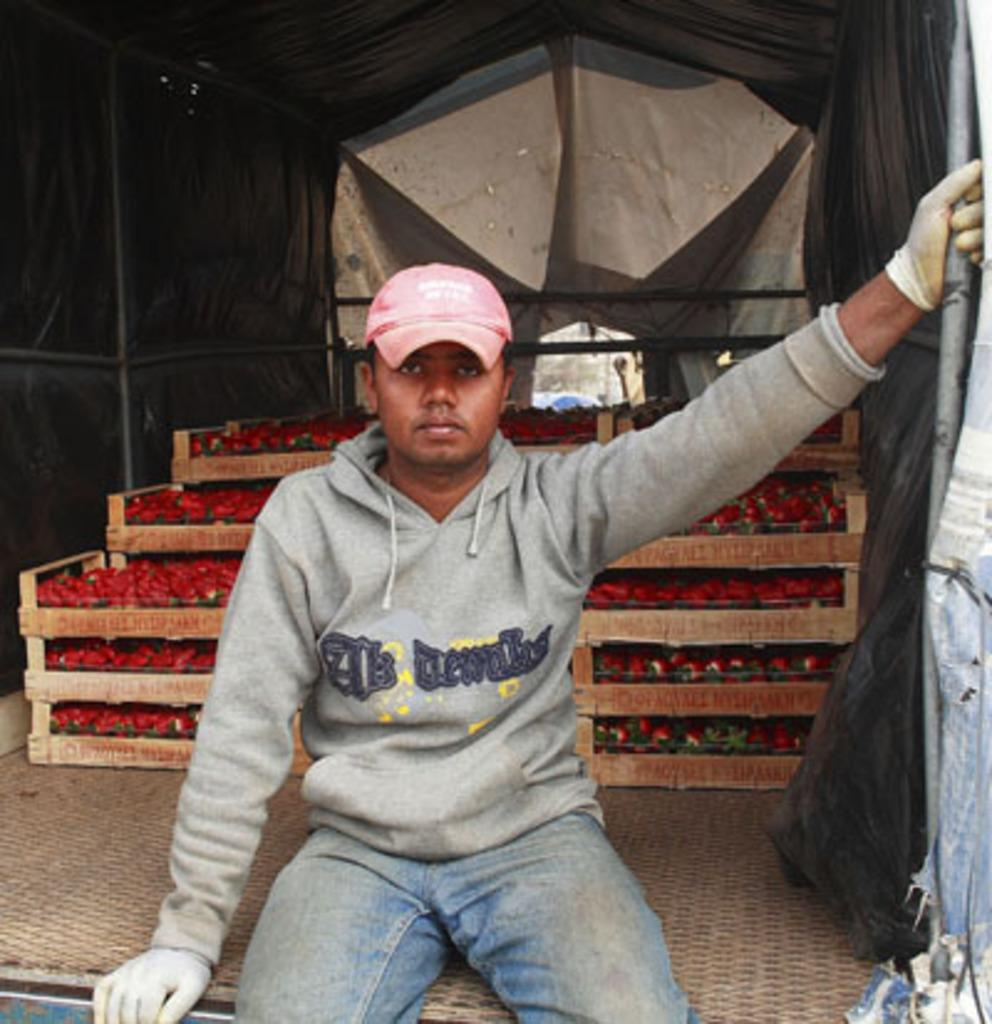What vehicle is present in the image? There is a truck in the image. Who is inside the truck? A person is sitting in the truck. What can be seen in the truck or near it? There are strawberry trays visible in the image. How many toes can be seen on the fish in the image? There are no fish or toes present in the image; it features of the truck, the person, and the strawberry trays are the focus. 